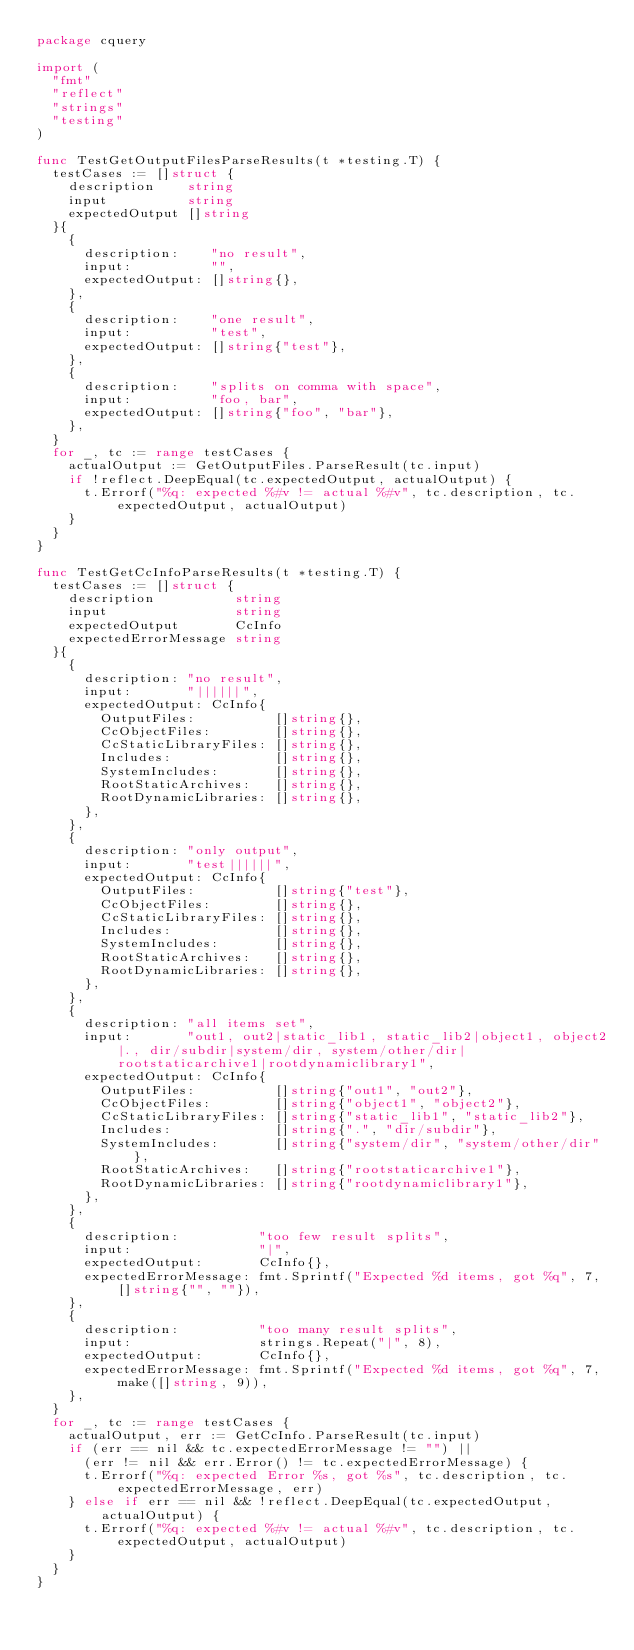Convert code to text. <code><loc_0><loc_0><loc_500><loc_500><_Go_>package cquery

import (
	"fmt"
	"reflect"
	"strings"
	"testing"
)

func TestGetOutputFilesParseResults(t *testing.T) {
	testCases := []struct {
		description    string
		input          string
		expectedOutput []string
	}{
		{
			description:    "no result",
			input:          "",
			expectedOutput: []string{},
		},
		{
			description:    "one result",
			input:          "test",
			expectedOutput: []string{"test"},
		},
		{
			description:    "splits on comma with space",
			input:          "foo, bar",
			expectedOutput: []string{"foo", "bar"},
		},
	}
	for _, tc := range testCases {
		actualOutput := GetOutputFiles.ParseResult(tc.input)
		if !reflect.DeepEqual(tc.expectedOutput, actualOutput) {
			t.Errorf("%q: expected %#v != actual %#v", tc.description, tc.expectedOutput, actualOutput)
		}
	}
}

func TestGetCcInfoParseResults(t *testing.T) {
	testCases := []struct {
		description          string
		input                string
		expectedOutput       CcInfo
		expectedErrorMessage string
	}{
		{
			description: "no result",
			input:       "||||||",
			expectedOutput: CcInfo{
				OutputFiles:          []string{},
				CcObjectFiles:        []string{},
				CcStaticLibraryFiles: []string{},
				Includes:             []string{},
				SystemIncludes:       []string{},
				RootStaticArchives:   []string{},
				RootDynamicLibraries: []string{},
			},
		},
		{
			description: "only output",
			input:       "test||||||",
			expectedOutput: CcInfo{
				OutputFiles:          []string{"test"},
				CcObjectFiles:        []string{},
				CcStaticLibraryFiles: []string{},
				Includes:             []string{},
				SystemIncludes:       []string{},
				RootStaticArchives:   []string{},
				RootDynamicLibraries: []string{},
			},
		},
		{
			description: "all items set",
			input:       "out1, out2|static_lib1, static_lib2|object1, object2|., dir/subdir|system/dir, system/other/dir|rootstaticarchive1|rootdynamiclibrary1",
			expectedOutput: CcInfo{
				OutputFiles:          []string{"out1", "out2"},
				CcObjectFiles:        []string{"object1", "object2"},
				CcStaticLibraryFiles: []string{"static_lib1", "static_lib2"},
				Includes:             []string{".", "dir/subdir"},
				SystemIncludes:       []string{"system/dir", "system/other/dir"},
				RootStaticArchives:   []string{"rootstaticarchive1"},
				RootDynamicLibraries: []string{"rootdynamiclibrary1"},
			},
		},
		{
			description:          "too few result splits",
			input:                "|",
			expectedOutput:       CcInfo{},
			expectedErrorMessage: fmt.Sprintf("Expected %d items, got %q", 7, []string{"", ""}),
		},
		{
			description:          "too many result splits",
			input:                strings.Repeat("|", 8),
			expectedOutput:       CcInfo{},
			expectedErrorMessage: fmt.Sprintf("Expected %d items, got %q", 7, make([]string, 9)),
		},
	}
	for _, tc := range testCases {
		actualOutput, err := GetCcInfo.ParseResult(tc.input)
		if (err == nil && tc.expectedErrorMessage != "") ||
			(err != nil && err.Error() != tc.expectedErrorMessage) {
			t.Errorf("%q: expected Error %s, got %s", tc.description, tc.expectedErrorMessage, err)
		} else if err == nil && !reflect.DeepEqual(tc.expectedOutput, actualOutput) {
			t.Errorf("%q: expected %#v != actual %#v", tc.description, tc.expectedOutput, actualOutput)
		}
	}
}
</code> 